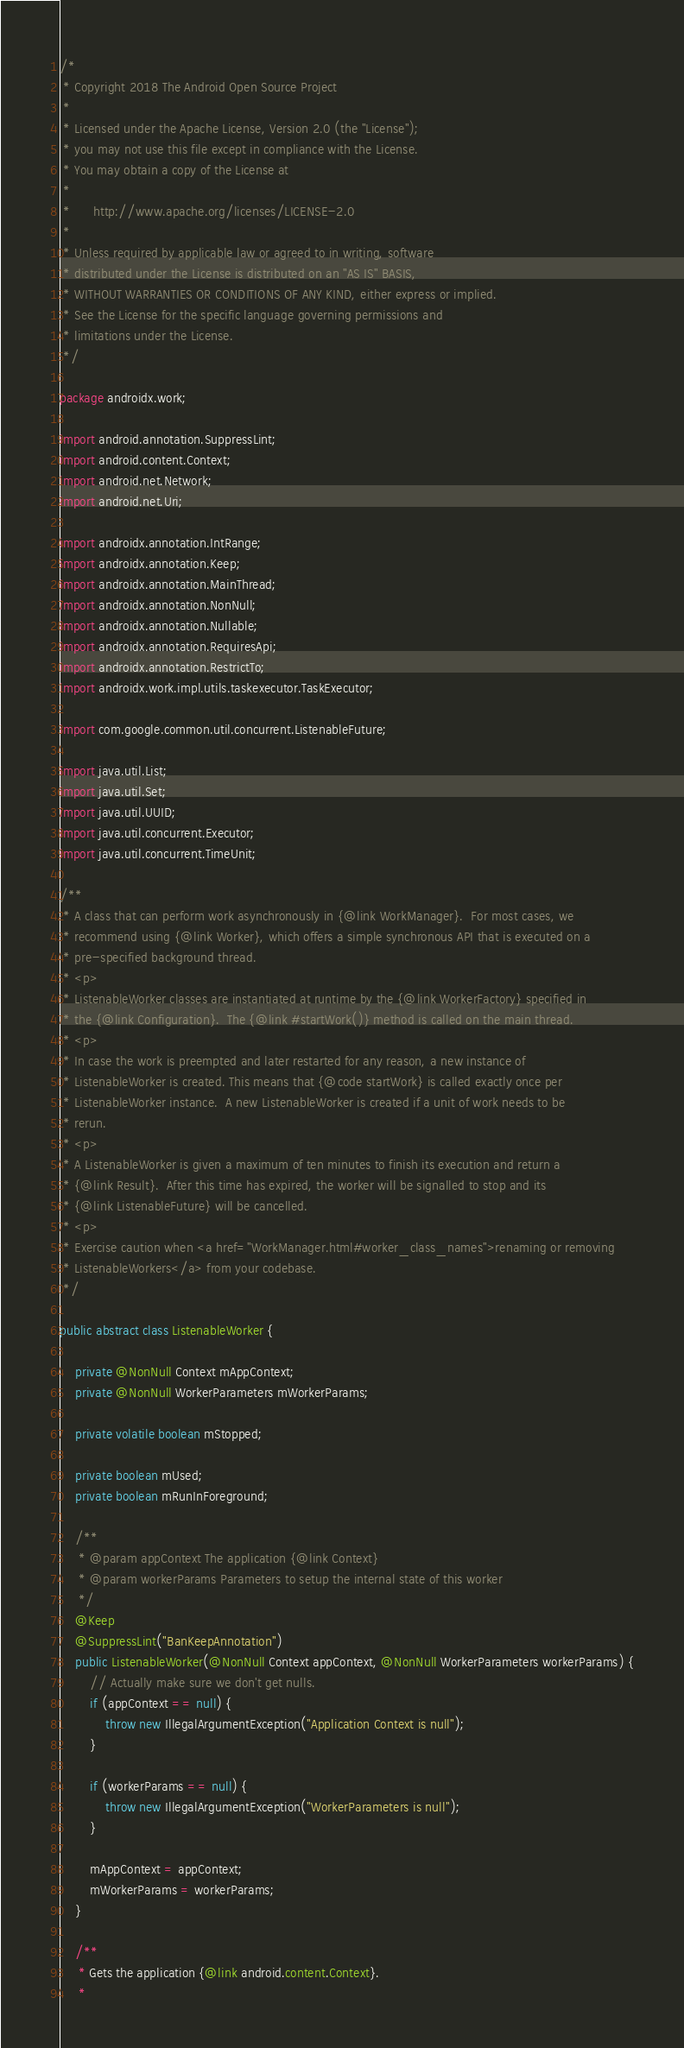Convert code to text. <code><loc_0><loc_0><loc_500><loc_500><_Java_>/*
 * Copyright 2018 The Android Open Source Project
 *
 * Licensed under the Apache License, Version 2.0 (the "License");
 * you may not use this file except in compliance with the License.
 * You may obtain a copy of the License at
 *
 *      http://www.apache.org/licenses/LICENSE-2.0
 *
 * Unless required by applicable law or agreed to in writing, software
 * distributed under the License is distributed on an "AS IS" BASIS,
 * WITHOUT WARRANTIES OR CONDITIONS OF ANY KIND, either express or implied.
 * See the License for the specific language governing permissions and
 * limitations under the License.
 */

package androidx.work;

import android.annotation.SuppressLint;
import android.content.Context;
import android.net.Network;
import android.net.Uri;

import androidx.annotation.IntRange;
import androidx.annotation.Keep;
import androidx.annotation.MainThread;
import androidx.annotation.NonNull;
import androidx.annotation.Nullable;
import androidx.annotation.RequiresApi;
import androidx.annotation.RestrictTo;
import androidx.work.impl.utils.taskexecutor.TaskExecutor;

import com.google.common.util.concurrent.ListenableFuture;

import java.util.List;
import java.util.Set;
import java.util.UUID;
import java.util.concurrent.Executor;
import java.util.concurrent.TimeUnit;

/**
 * A class that can perform work asynchronously in {@link WorkManager}.  For most cases, we
 * recommend using {@link Worker}, which offers a simple synchronous API that is executed on a
 * pre-specified background thread.
 * <p>
 * ListenableWorker classes are instantiated at runtime by the {@link WorkerFactory} specified in
 * the {@link Configuration}.  The {@link #startWork()} method is called on the main thread.
 * <p>
 * In case the work is preempted and later restarted for any reason, a new instance of
 * ListenableWorker is created. This means that {@code startWork} is called exactly once per
 * ListenableWorker instance.  A new ListenableWorker is created if a unit of work needs to be
 * rerun.
 * <p>
 * A ListenableWorker is given a maximum of ten minutes to finish its execution and return a
 * {@link Result}.  After this time has expired, the worker will be signalled to stop and its
 * {@link ListenableFuture} will be cancelled.
 * <p>
 * Exercise caution when <a href="WorkManager.html#worker_class_names">renaming or removing
 * ListenableWorkers</a> from your codebase.
 */

public abstract class ListenableWorker {

    private @NonNull Context mAppContext;
    private @NonNull WorkerParameters mWorkerParams;

    private volatile boolean mStopped;

    private boolean mUsed;
    private boolean mRunInForeground;

    /**
     * @param appContext The application {@link Context}
     * @param workerParams Parameters to setup the internal state of this worker
     */
    @Keep
    @SuppressLint("BanKeepAnnotation")
    public ListenableWorker(@NonNull Context appContext, @NonNull WorkerParameters workerParams) {
        // Actually make sure we don't get nulls.
        if (appContext == null) {
            throw new IllegalArgumentException("Application Context is null");
        }

        if (workerParams == null) {
            throw new IllegalArgumentException("WorkerParameters is null");
        }

        mAppContext = appContext;
        mWorkerParams = workerParams;
    }

    /**
     * Gets the application {@link android.content.Context}.
     *</code> 